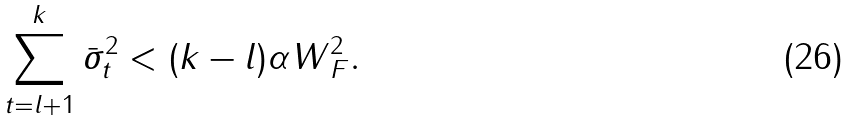<formula> <loc_0><loc_0><loc_500><loc_500>\sum _ { t = l + 1 } ^ { k } \bar { \sigma } ^ { 2 } _ { t } < ( k - l ) \alpha \| W \| _ { F } ^ { 2 } .</formula> 